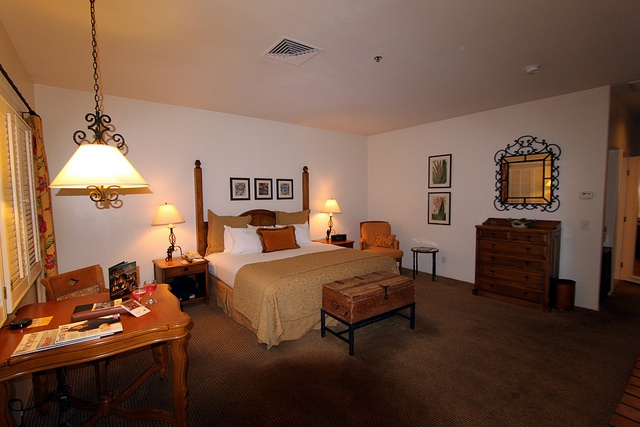Describe the objects in this image and their specific colors. I can see bed in tan, brown, gray, and maroon tones, dining table in tan, maroon, brown, and black tones, chair in tan, maroon, and brown tones, book in tan, maroon, and black tones, and chair in tan, brown, maroon, and black tones in this image. 